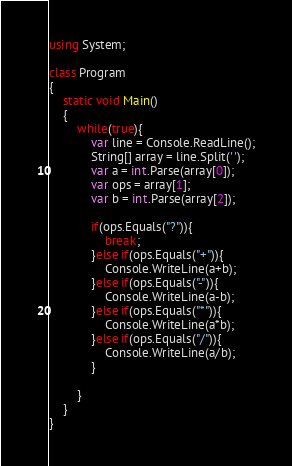Convert code to text. <code><loc_0><loc_0><loc_500><loc_500><_C#_>using System;

class Program
{
    static void Main()
    {
        while(true){
            var line = Console.ReadLine();
            String[] array = line.Split(' ');
            var a = int.Parse(array[0]);
            var ops = array[1];
            var b = int.Parse(array[2]);
            
            if(ops.Equals("?")){
                break;
            }else if(ops.Equals("+")){
                Console.WriteLine(a+b);
            }else if(ops.Equals("-")){
                Console.WriteLine(a-b);
            }else if(ops.Equals("*")){
                Console.WriteLine(a*b);
            }else if(ops.Equals("/")){
                Console.WriteLine(a/b);
            }
            
        }
    }
}

</code> 